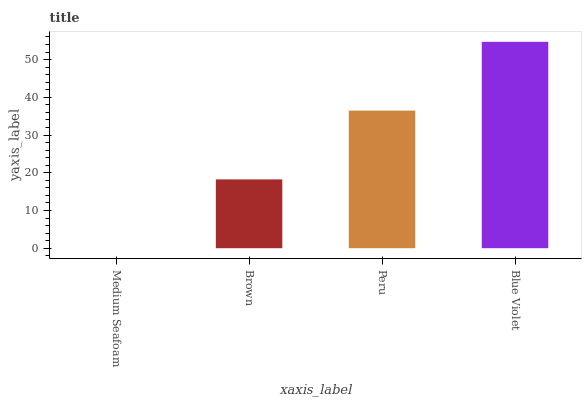Is Brown the minimum?
Answer yes or no. No. Is Brown the maximum?
Answer yes or no. No. Is Brown greater than Medium Seafoam?
Answer yes or no. Yes. Is Medium Seafoam less than Brown?
Answer yes or no. Yes. Is Medium Seafoam greater than Brown?
Answer yes or no. No. Is Brown less than Medium Seafoam?
Answer yes or no. No. Is Peru the high median?
Answer yes or no. Yes. Is Brown the low median?
Answer yes or no. Yes. Is Brown the high median?
Answer yes or no. No. Is Blue Violet the low median?
Answer yes or no. No. 